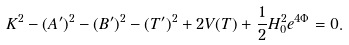Convert formula to latex. <formula><loc_0><loc_0><loc_500><loc_500>K ^ { 2 } - ( A ^ { \prime } ) ^ { 2 } - ( B ^ { \prime } ) ^ { 2 } - ( T ^ { \prime } ) ^ { 2 } + 2 V ( T ) + \frac { 1 } { 2 } H _ { 0 } ^ { 2 } e ^ { 4 \Phi } = 0 .</formula> 